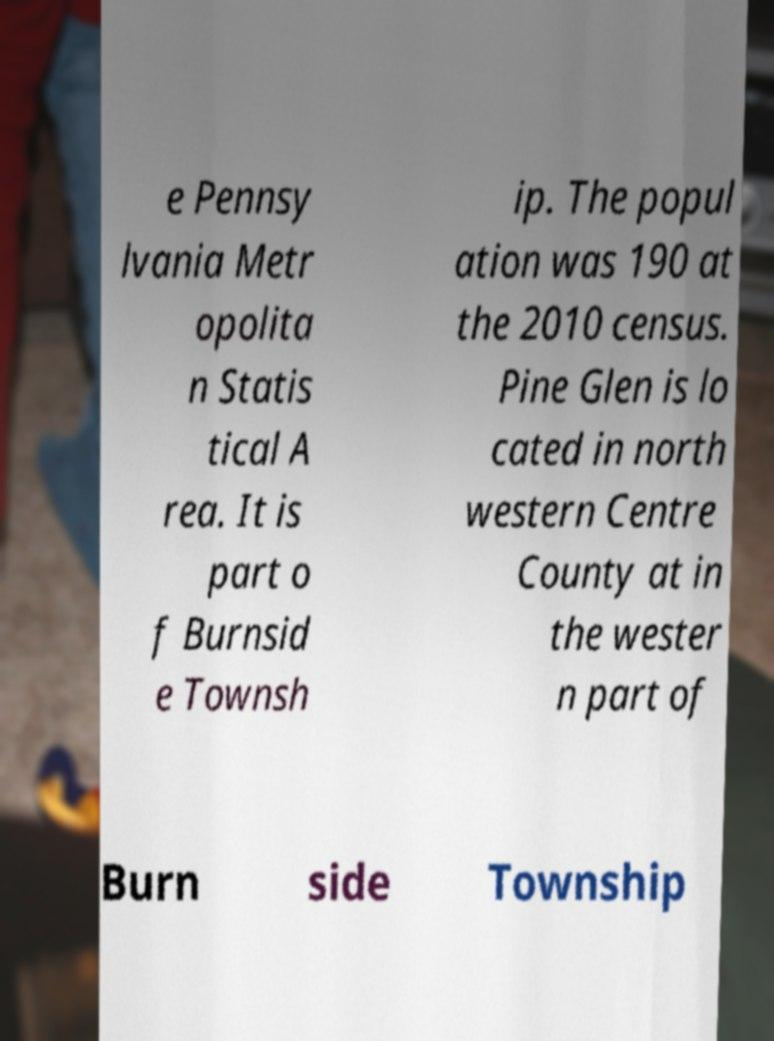There's text embedded in this image that I need extracted. Can you transcribe it verbatim? e Pennsy lvania Metr opolita n Statis tical A rea. It is part o f Burnsid e Townsh ip. The popul ation was 190 at the 2010 census. Pine Glen is lo cated in north western Centre County at in the wester n part of Burn side Township 